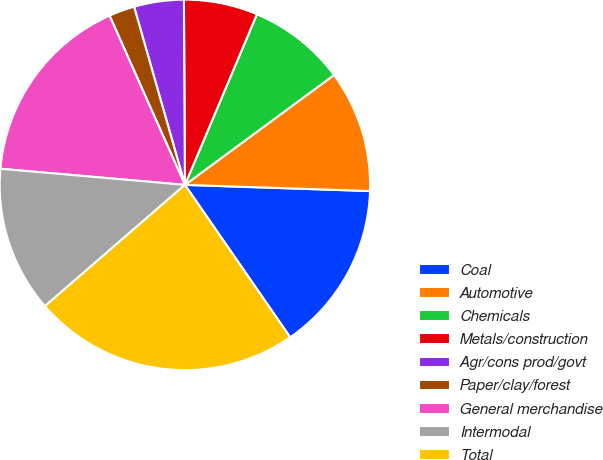<chart> <loc_0><loc_0><loc_500><loc_500><pie_chart><fcel>Coal<fcel>Automotive<fcel>Chemicals<fcel>Metals/construction<fcel>Agr/cons prod/govt<fcel>Paper/clay/forest<fcel>General merchandise<fcel>Intermodal<fcel>Total<nl><fcel>14.85%<fcel>10.64%<fcel>8.54%<fcel>6.44%<fcel>4.34%<fcel>2.24%<fcel>16.95%<fcel>12.75%<fcel>23.26%<nl></chart> 